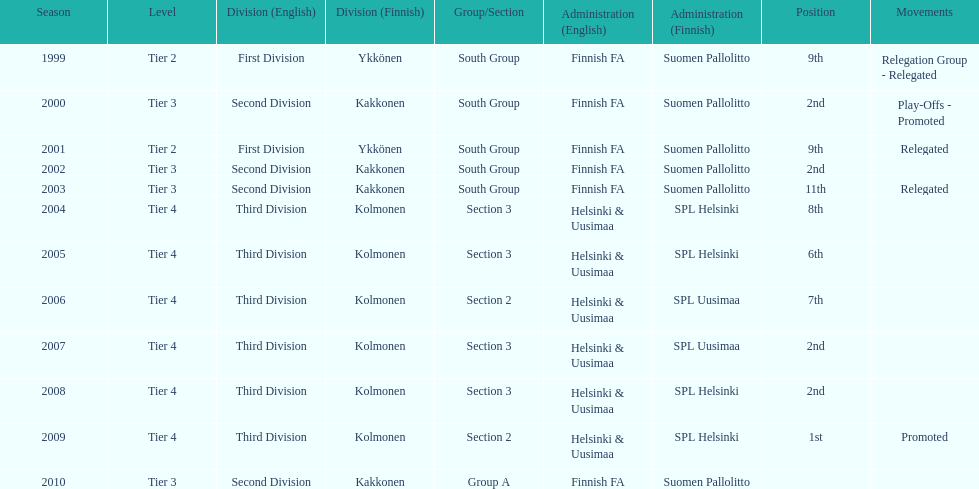When was the last year they placed 2nd? 2008. 